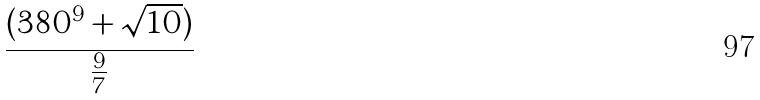Convert formula to latex. <formula><loc_0><loc_0><loc_500><loc_500>\frac { ( 3 8 0 ^ { 9 } + \sqrt { 1 0 } ) } { \frac { 9 } { 7 } }</formula> 